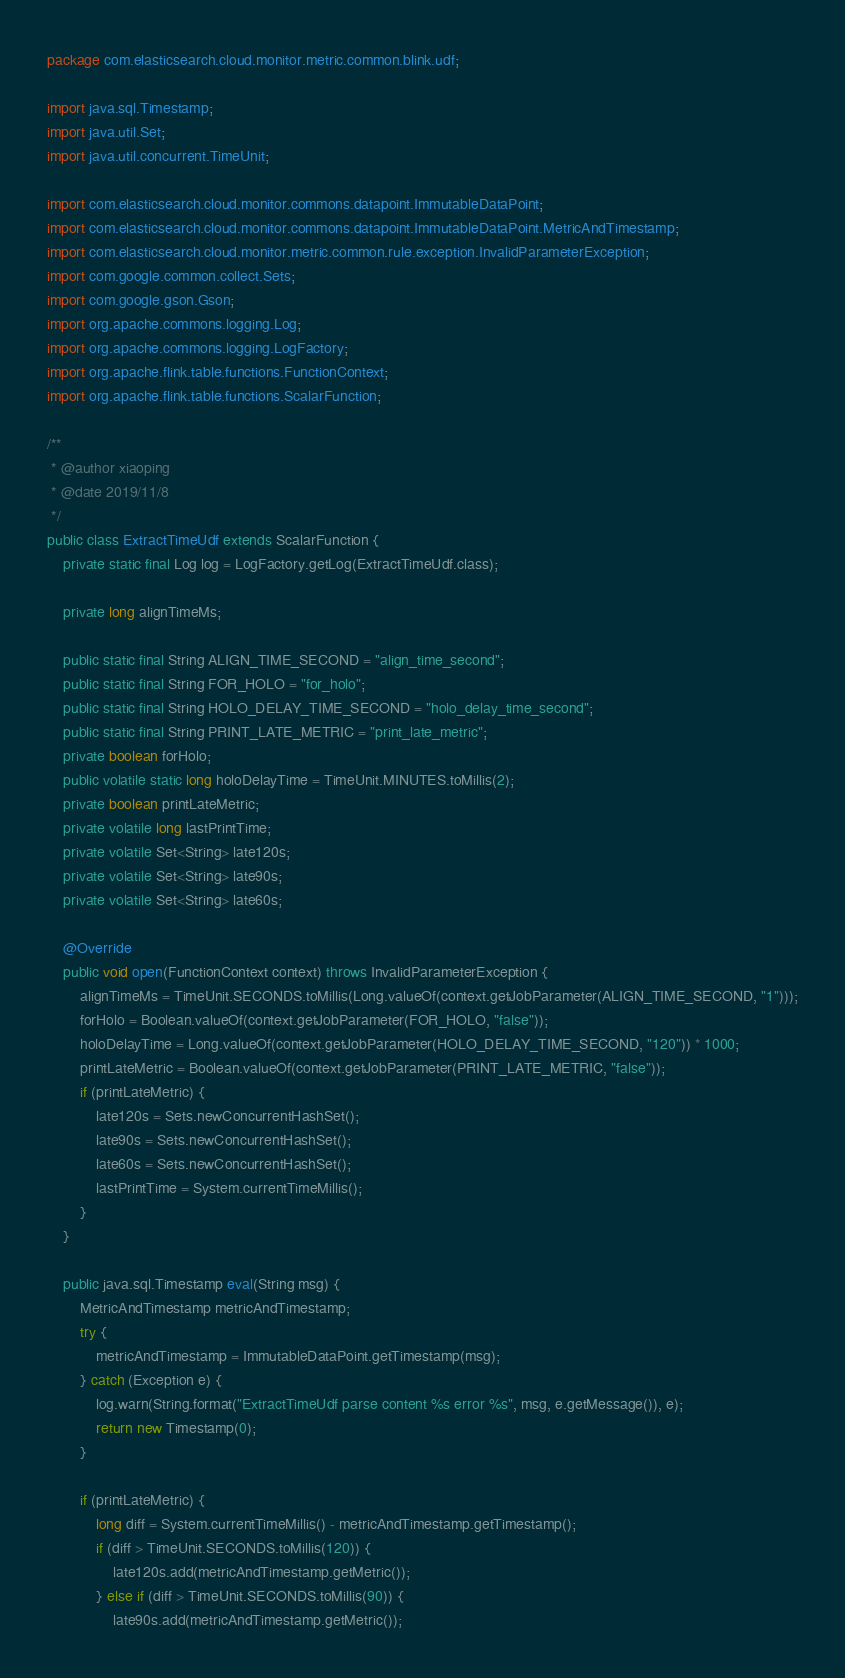<code> <loc_0><loc_0><loc_500><loc_500><_Java_>package com.elasticsearch.cloud.monitor.metric.common.blink.udf;

import java.sql.Timestamp;
import java.util.Set;
import java.util.concurrent.TimeUnit;

import com.elasticsearch.cloud.monitor.commons.datapoint.ImmutableDataPoint;
import com.elasticsearch.cloud.monitor.commons.datapoint.ImmutableDataPoint.MetricAndTimestamp;
import com.elasticsearch.cloud.monitor.metric.common.rule.exception.InvalidParameterException;
import com.google.common.collect.Sets;
import com.google.gson.Gson;
import org.apache.commons.logging.Log;
import org.apache.commons.logging.LogFactory;
import org.apache.flink.table.functions.FunctionContext;
import org.apache.flink.table.functions.ScalarFunction;

/**
 * @author xiaoping
 * @date 2019/11/8
 */
public class ExtractTimeUdf extends ScalarFunction {
    private static final Log log = LogFactory.getLog(ExtractTimeUdf.class);

    private long alignTimeMs;

    public static final String ALIGN_TIME_SECOND = "align_time_second";
    public static final String FOR_HOLO = "for_holo";
    public static final String HOLO_DELAY_TIME_SECOND = "holo_delay_time_second";
    public static final String PRINT_LATE_METRIC = "print_late_metric";
    private boolean forHolo;
    public volatile static long holoDelayTime = TimeUnit.MINUTES.toMillis(2);
    private boolean printLateMetric;
    private volatile long lastPrintTime;
    private volatile Set<String> late120s;
    private volatile Set<String> late90s;
    private volatile Set<String> late60s;

    @Override
    public void open(FunctionContext context) throws InvalidParameterException {
        alignTimeMs = TimeUnit.SECONDS.toMillis(Long.valueOf(context.getJobParameter(ALIGN_TIME_SECOND, "1")));
        forHolo = Boolean.valueOf(context.getJobParameter(FOR_HOLO, "false"));
        holoDelayTime = Long.valueOf(context.getJobParameter(HOLO_DELAY_TIME_SECOND, "120")) * 1000;
        printLateMetric = Boolean.valueOf(context.getJobParameter(PRINT_LATE_METRIC, "false"));
        if (printLateMetric) {
            late120s = Sets.newConcurrentHashSet();
            late90s = Sets.newConcurrentHashSet();
            late60s = Sets.newConcurrentHashSet();
            lastPrintTime = System.currentTimeMillis();
        }
    }

    public java.sql.Timestamp eval(String msg) {
        MetricAndTimestamp metricAndTimestamp;
        try {
            metricAndTimestamp = ImmutableDataPoint.getTimestamp(msg);
        } catch (Exception e) {
            log.warn(String.format("ExtractTimeUdf parse content %s error %s", msg, e.getMessage()), e);
            return new Timestamp(0);
        }

        if (printLateMetric) {
            long diff = System.currentTimeMillis() - metricAndTimestamp.getTimestamp();
            if (diff > TimeUnit.SECONDS.toMillis(120)) {
                late120s.add(metricAndTimestamp.getMetric());
            } else if (diff > TimeUnit.SECONDS.toMillis(90)) {
                late90s.add(metricAndTimestamp.getMetric());</code> 